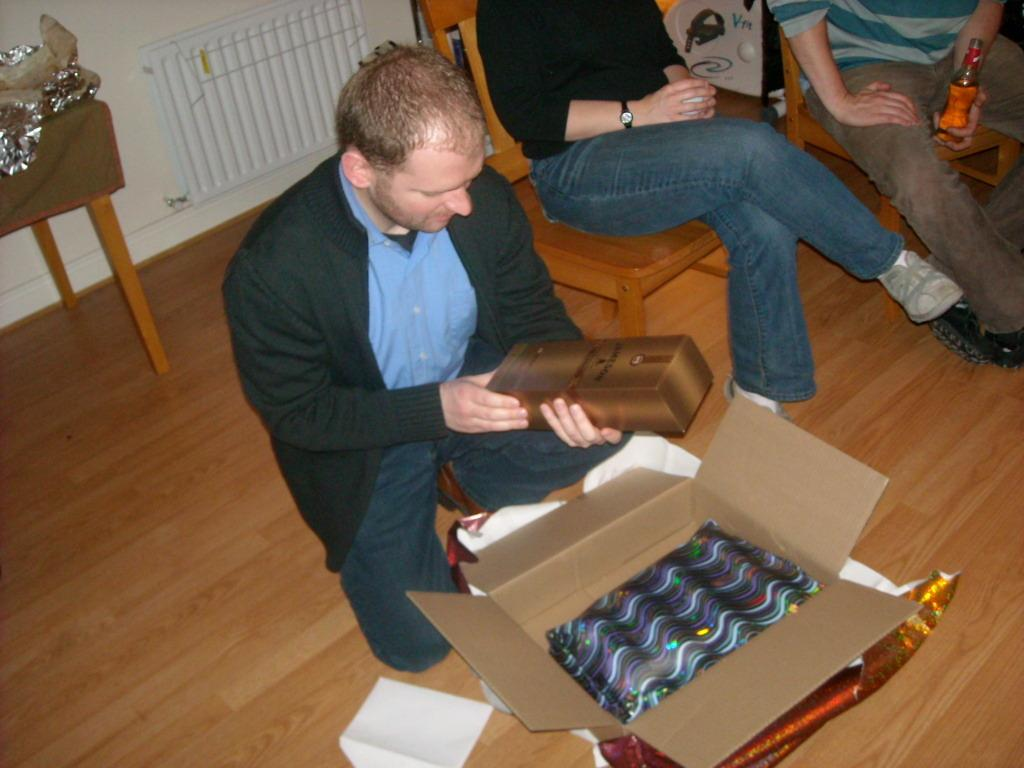What are the persons in the image doing? The persons in the image are sitting. What objects are present for the persons to sit on? There are chairs in the image. What items are being held by the persons? One person is holding a bottle, and another person is holding a box. What can be found on the floor in the image? There is a cardboard box on the floor. What is visible in the background of the image? There is a wall visible in the background. Can you see an owl perched on the wall in the image? There is no owl present in the image; only the persons, chairs, bottles, boxes, and wall are visible. 